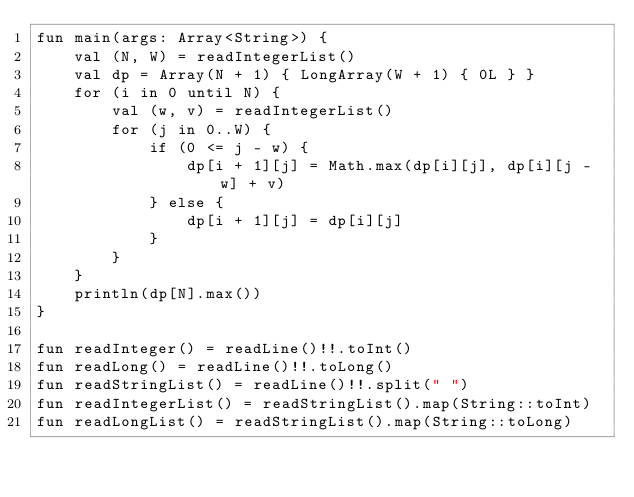<code> <loc_0><loc_0><loc_500><loc_500><_Kotlin_>fun main(args: Array<String>) {
    val (N, W) = readIntegerList()
    val dp = Array(N + 1) { LongArray(W + 1) { 0L } }
    for (i in 0 until N) {
        val (w, v) = readIntegerList()
        for (j in 0..W) {
            if (0 <= j - w) {
                dp[i + 1][j] = Math.max(dp[i][j], dp[i][j - w] + v)
            } else {
                dp[i + 1][j] = dp[i][j]
            }
        }
    }
    println(dp[N].max())
}

fun readInteger() = readLine()!!.toInt()
fun readLong() = readLine()!!.toLong()
fun readStringList() = readLine()!!.split(" ")
fun readIntegerList() = readStringList().map(String::toInt)
fun readLongList() = readStringList().map(String::toLong)
</code> 